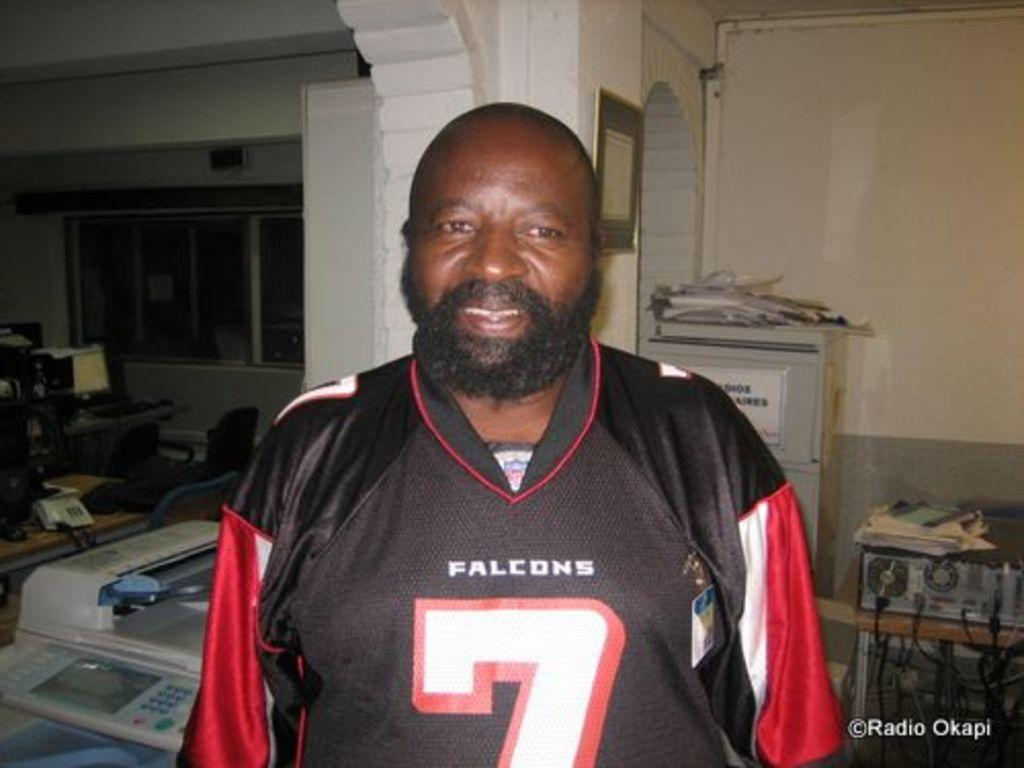<image>
Relay a brief, clear account of the picture shown. a Falcons player number 7 wearing a red and black jersey top 